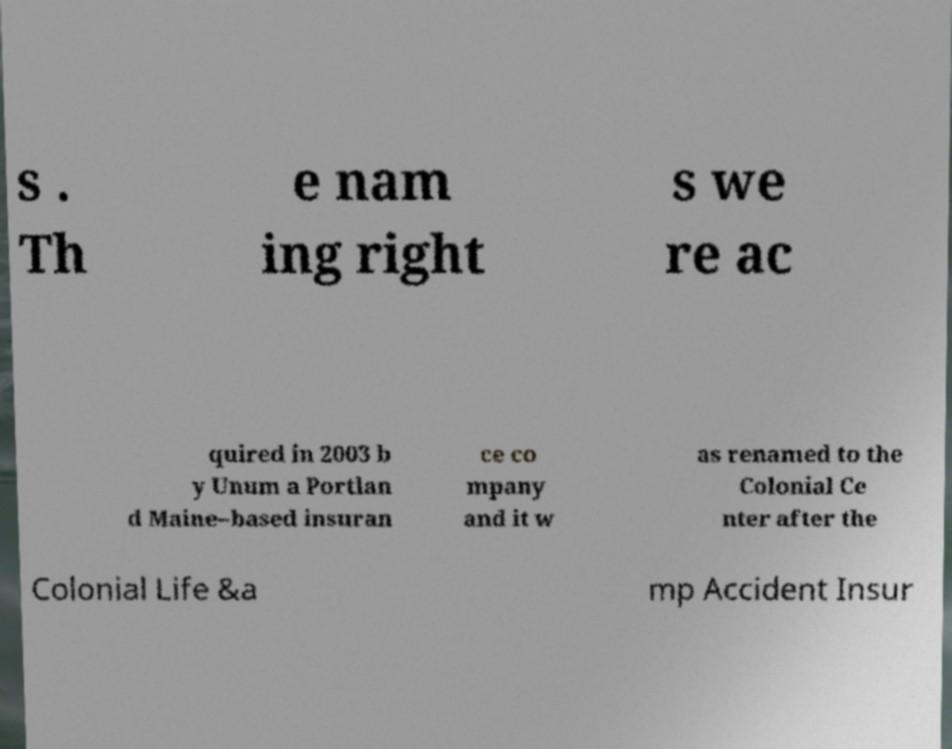What messages or text are displayed in this image? I need them in a readable, typed format. s . Th e nam ing right s we re ac quired in 2003 b y Unum a Portlan d Maine–based insuran ce co mpany and it w as renamed to the Colonial Ce nter after the Colonial Life &a mp Accident Insur 